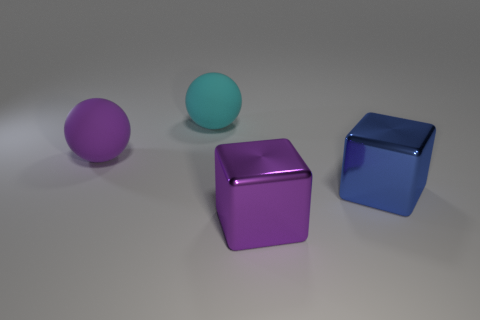Add 1 tiny cyan matte cubes. How many objects exist? 5 Add 2 small brown spheres. How many small brown spheres exist? 2 Subtract 0 yellow cubes. How many objects are left? 4 Subtract all blue metal cubes. Subtract all cyan things. How many objects are left? 2 Add 2 purple rubber objects. How many purple rubber objects are left? 3 